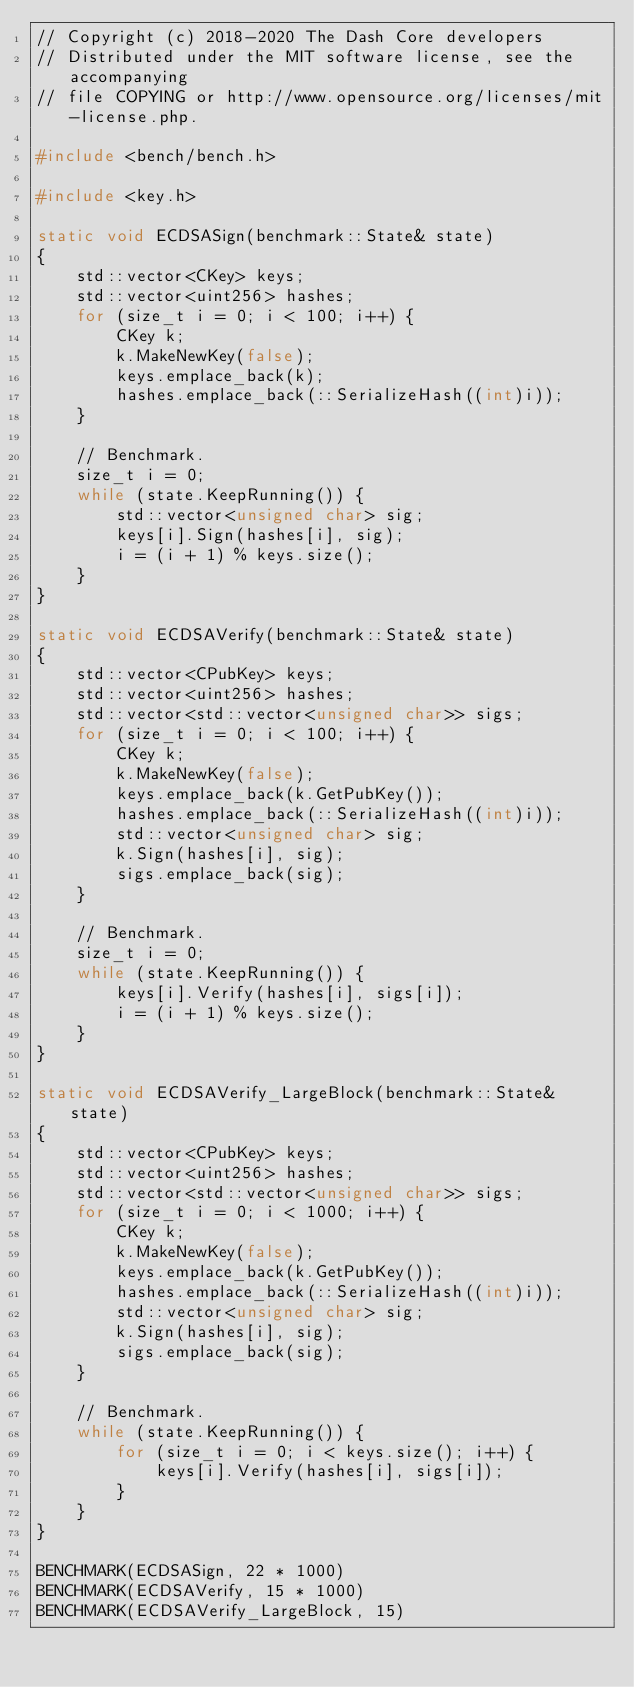Convert code to text. <code><loc_0><loc_0><loc_500><loc_500><_C++_>// Copyright (c) 2018-2020 The Dash Core developers
// Distributed under the MIT software license, see the accompanying
// file COPYING or http://www.opensource.org/licenses/mit-license.php.

#include <bench/bench.h>

#include <key.h>

static void ECDSASign(benchmark::State& state)
{
    std::vector<CKey> keys;
    std::vector<uint256> hashes;
    for (size_t i = 0; i < 100; i++) {
        CKey k;
        k.MakeNewKey(false);
        keys.emplace_back(k);
        hashes.emplace_back(::SerializeHash((int)i));
    }

    // Benchmark.
    size_t i = 0;
    while (state.KeepRunning()) {
        std::vector<unsigned char> sig;
        keys[i].Sign(hashes[i], sig);
        i = (i + 1) % keys.size();
    }
}

static void ECDSAVerify(benchmark::State& state)
{
    std::vector<CPubKey> keys;
    std::vector<uint256> hashes;
    std::vector<std::vector<unsigned char>> sigs;
    for (size_t i = 0; i < 100; i++) {
        CKey k;
        k.MakeNewKey(false);
        keys.emplace_back(k.GetPubKey());
        hashes.emplace_back(::SerializeHash((int)i));
        std::vector<unsigned char> sig;
        k.Sign(hashes[i], sig);
        sigs.emplace_back(sig);
    }

    // Benchmark.
    size_t i = 0;
    while (state.KeepRunning()) {
        keys[i].Verify(hashes[i], sigs[i]);
        i = (i + 1) % keys.size();
    }
}

static void ECDSAVerify_LargeBlock(benchmark::State& state)
{
    std::vector<CPubKey> keys;
    std::vector<uint256> hashes;
    std::vector<std::vector<unsigned char>> sigs;
    for (size_t i = 0; i < 1000; i++) {
        CKey k;
        k.MakeNewKey(false);
        keys.emplace_back(k.GetPubKey());
        hashes.emplace_back(::SerializeHash((int)i));
        std::vector<unsigned char> sig;
        k.Sign(hashes[i], sig);
        sigs.emplace_back(sig);
    }

    // Benchmark.
    while (state.KeepRunning()) {
        for (size_t i = 0; i < keys.size(); i++) {
            keys[i].Verify(hashes[i], sigs[i]);
        }
    }
}

BENCHMARK(ECDSASign, 22 * 1000)
BENCHMARK(ECDSAVerify, 15 * 1000)
BENCHMARK(ECDSAVerify_LargeBlock, 15)
</code> 